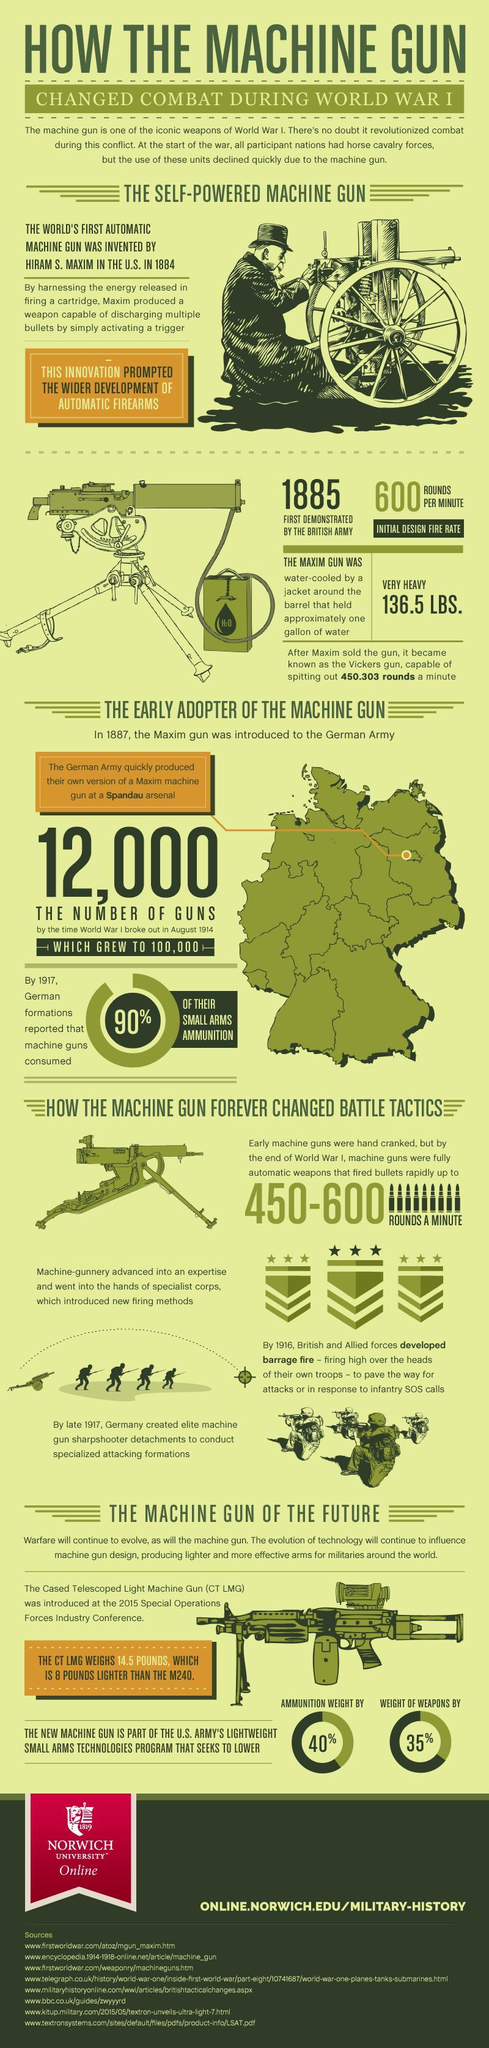How many sources are listed at the bottom?
Answer the question with a short phrase. 8 